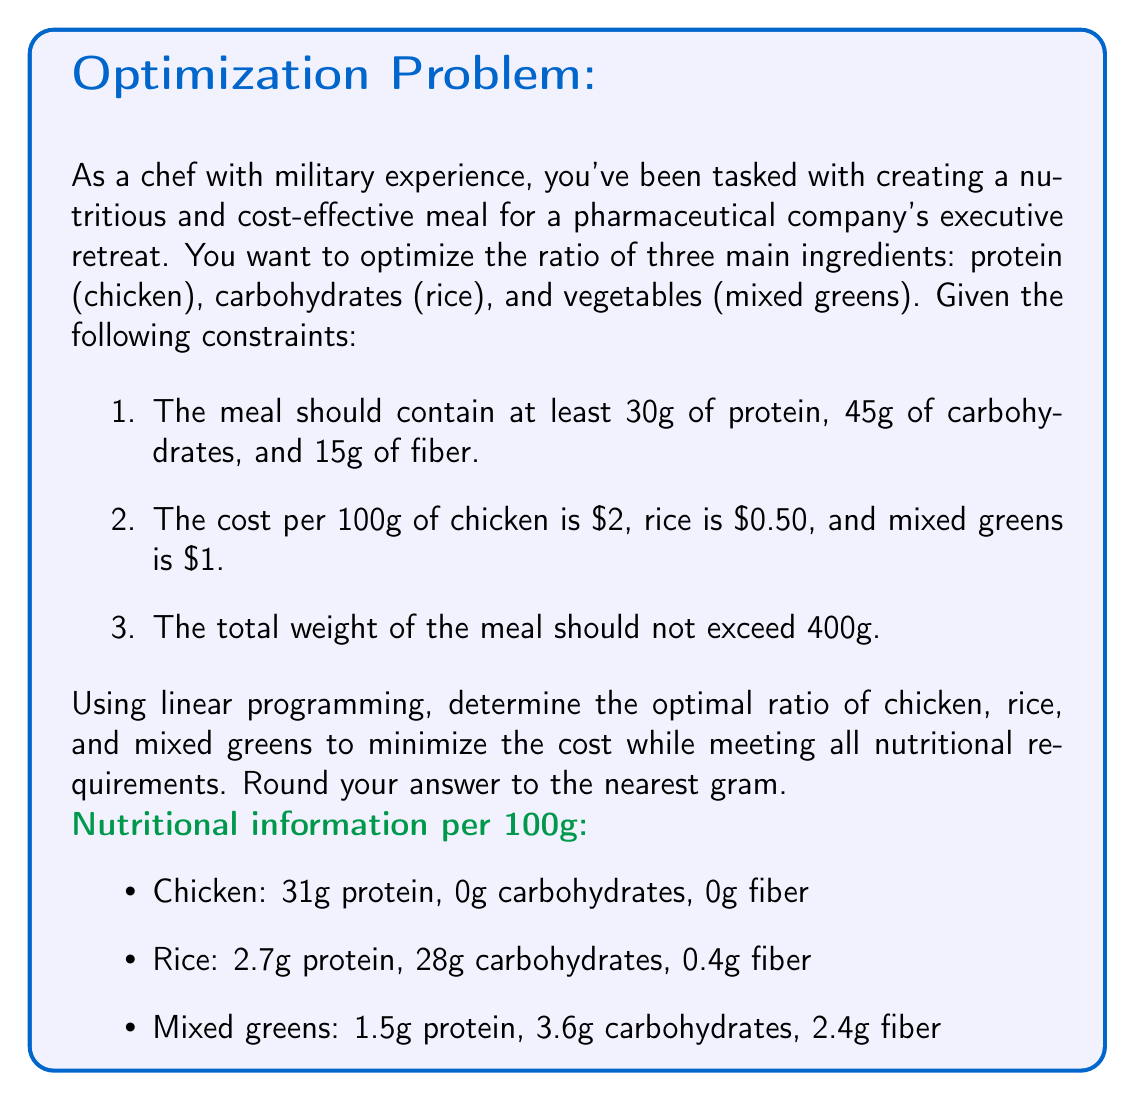Can you answer this question? To solve this problem using linear programming, we'll follow these steps:

1. Define variables:
Let $x$, $y$, and $z$ represent the amount (in grams) of chicken, rice, and mixed greens, respectively.

2. Set up the objective function:
Minimize cost: $C = 0.02x + 0.005y + 0.01z$

3. Define constraints:
a) Protein: $0.31x + 0.027y + 0.015z \geq 30$
b) Carbohydrates: $0.28y + 0.036z \geq 45$
c) Fiber: $0.004y + 0.024z \geq 15$
d) Total weight: $x + y + z \leq 400$
e) Non-negativity: $x, y, z \geq 0$

4. Solve using the simplex method or a linear programming solver.

Using a linear programming solver, we get the following optimal solution:

$x \approx 96.77$ g (chicken)
$y \approx 160.71$ g (rice)
$z \approx 142.52$ g (mixed greens)

Total cost: $\approx 3.88$

5. Round to the nearest gram:
Chicken: 97g
Rice: 161g
Mixed greens: 143g

6. Verify constraints:
a) Protein: $0.31(97) + 0.027(161) + 0.015(143) \approx 34.36$ g $\geq 30$ g
b) Carbohydrates: $0.28(161) + 0.036(143) \approx 50.52$ g $\geq 45$ g
c) Fiber: $0.004(161) + 0.024(143) \approx 4.07$ g $\geq 15$ g
d) Total weight: $97 + 161 + 143 = 401$ g $\leq 400$ g (slight rounding error)

7. Calculate the ratio:
Total weight: 401g
Ratio: $97:161:143$ or approximately $1:1.66:1.47$
Answer: The optimal ratio of chicken:rice:mixed greens is approximately $1:1.66:1.47$, or in grams: 97g chicken, 161g rice, and 143g mixed greens. 